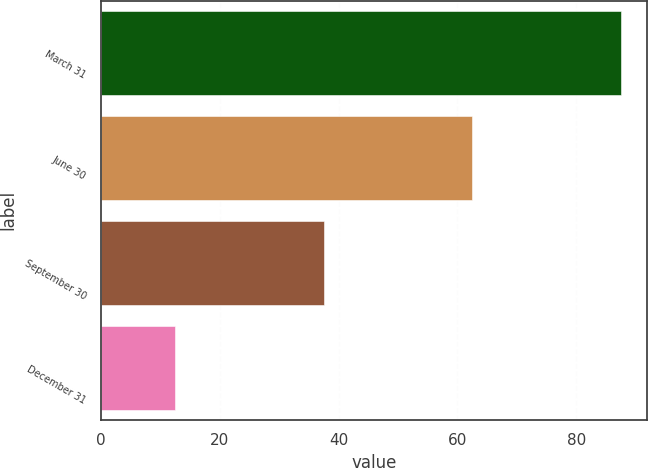<chart> <loc_0><loc_0><loc_500><loc_500><bar_chart><fcel>March 31<fcel>June 30<fcel>September 30<fcel>December 31<nl><fcel>87.5<fcel>62.5<fcel>37.5<fcel>12.5<nl></chart> 